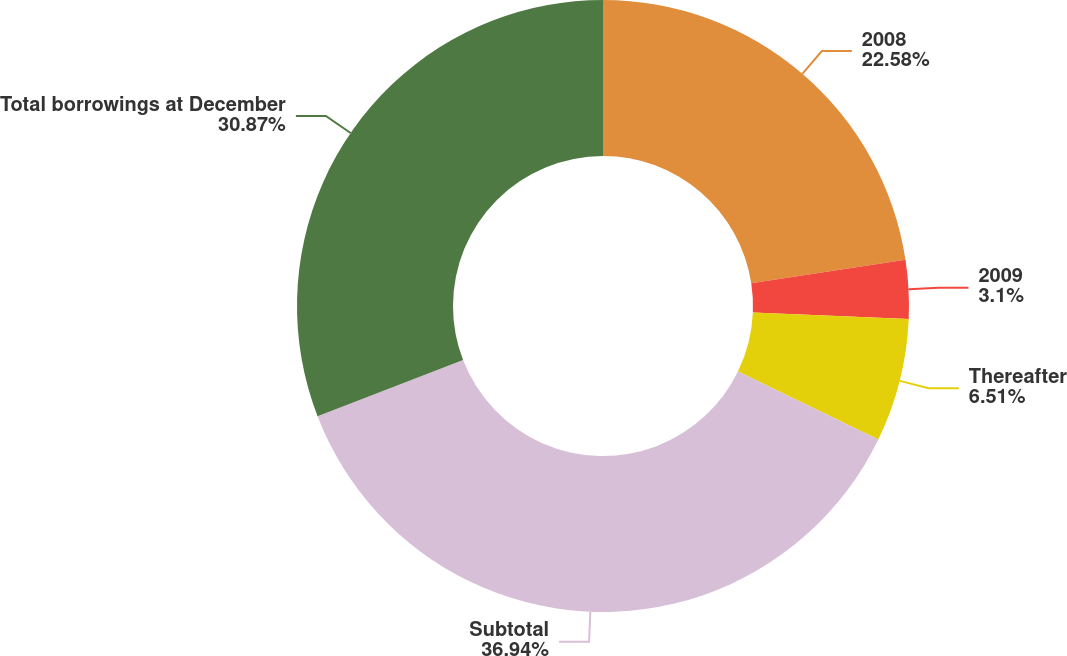<chart> <loc_0><loc_0><loc_500><loc_500><pie_chart><fcel>2008<fcel>2009<fcel>Thereafter<fcel>Subtotal<fcel>Total borrowings at December<nl><fcel>22.58%<fcel>3.1%<fcel>6.51%<fcel>36.94%<fcel>30.87%<nl></chart> 